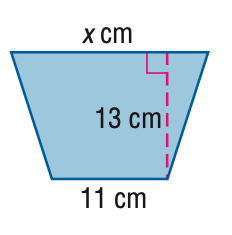Answer the mathemtical geometry problem and directly provide the correct option letter.
Question: Find x. A = 177 cm^2.
Choices: A: 13.6 B: 14.8 C: 16.1 D: 16.2 D 